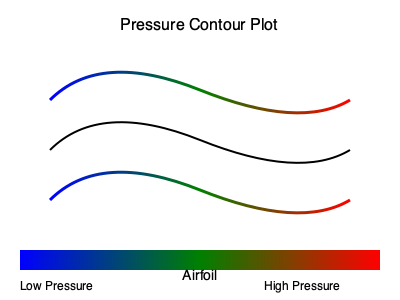Based on the pressure contour plot shown for airflow around an airfoil, which region experiences the highest pressure, and how does this relate to the principle of lift generation? To interpret the pressure contour plot and understand its relation to lift generation, let's follow these steps:

1. Pressure distribution:
   - The color gradient represents pressure levels, with blue indicating low pressure and red indicating high pressure.
   - Observe that the pressure is higher (more red) on the bottom surface of the airfoil and lower (more blue) on the top surface.

2. Bernoulli's principle:
   - Bernoulli's equation states that for inviscid, incompressible flow: $P + \frac{1}{2}\rho V^2 = \text{constant}$
   - Where $P$ is pressure, $\rho$ is density, and $V$ is velocity.

3. Flow behavior:
   - Air moves faster over the curved upper surface of the airfoil.
   - This increased velocity results in lower pressure on the top surface.

4. Pressure difference:
   - The pressure difference between the lower and upper surfaces creates a net upward force.
   - This force is the lift, given by: $L = \int (P_l - P_u) dA$
   - Where $L$ is lift, $P_l$ is lower surface pressure, $P_u$ is upper surface pressure, and $A$ is the surface area.

5. Lift generation:
   - The highest pressure region (red) is on the bottom surface of the airfoil.
   - This high-pressure area, combined with the low-pressure area above, generates lift.

6. Circulation theory:
   - The pressure distribution also relates to circulation ($\Gamma$) around the airfoil.
   - Lift can be expressed as: $L = \rho V_\infty \Gamma$
   - Where $\rho$ is density, $V_\infty$ is freestream velocity, and $\Gamma$ is circulation.

In summary, the highest pressure region on the bottom surface of the airfoil, coupled with the lower pressure on the top surface, creates the pressure difference necessary for lift generation, aligning with both Bernoulli's principle and circulation theory in aerodynamics.
Answer: Bottom surface; pressure difference creates lift 